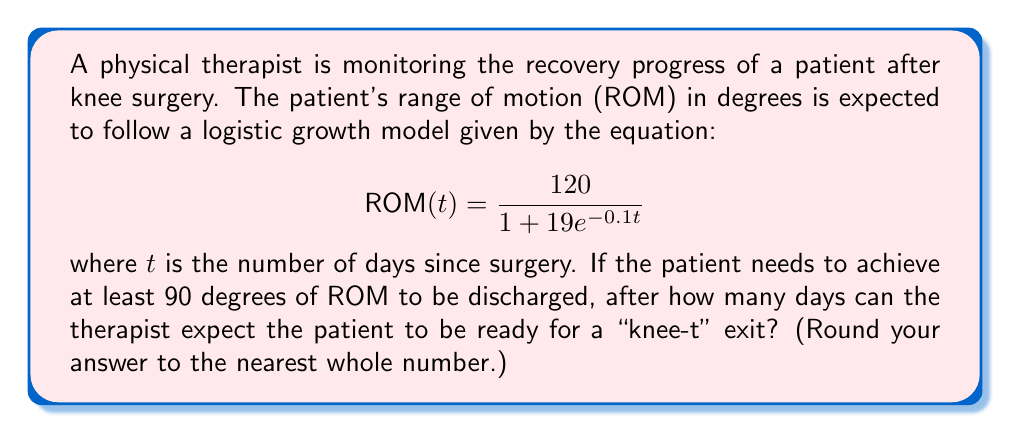Teach me how to tackle this problem. To solve this problem, we need to follow these steps:

1) We want to find $t$ when $ROM(t) = 90$ degrees. So, we set up the equation:

   $$90 = \frac{120}{1 + 19e^{-0.1t}}$$

2) Multiply both sides by $(1 + 19e^{-0.1t})$:

   $$90(1 + 19e^{-0.1t}) = 120$$

3) Expand the left side:

   $$90 + 1710e^{-0.1t} = 120$$

4) Subtract 90 from both sides:

   $$1710e^{-0.1t} = 30$$

5) Divide both sides by 1710:

   $$e^{-0.1t} = \frac{30}{1710} = \frac{1}{57}$$

6) Take the natural log of both sides:

   $$-0.1t = \ln(\frac{1}{57})$$

7) Divide both sides by -0.1:

   $$t = -10\ln(\frac{1}{57}) = 10\ln(57)$$

8) Calculate and round to the nearest whole number:

   $$t \approx 40.43 \approx 40$$

Therefore, the therapist can expect the patient to be ready for discharge after approximately 40 days.
Answer: 40 days 